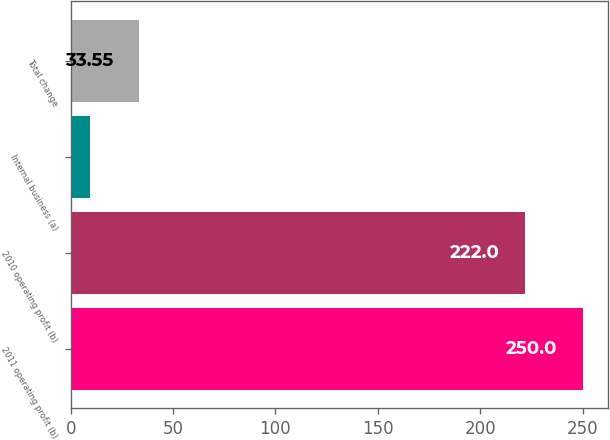Convert chart. <chart><loc_0><loc_0><loc_500><loc_500><bar_chart><fcel>2011 operating profit (b)<fcel>2010 operating profit (b)<fcel>Internal business (a)<fcel>Total change<nl><fcel>250<fcel>222<fcel>9.5<fcel>33.55<nl></chart> 